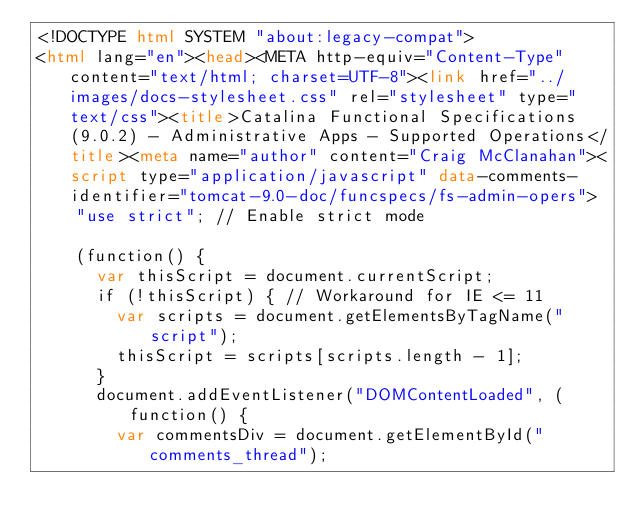Convert code to text. <code><loc_0><loc_0><loc_500><loc_500><_HTML_><!DOCTYPE html SYSTEM "about:legacy-compat">
<html lang="en"><head><META http-equiv="Content-Type" content="text/html; charset=UTF-8"><link href="../images/docs-stylesheet.css" rel="stylesheet" type="text/css"><title>Catalina Functional Specifications (9.0.2) - Administrative Apps - Supported Operations</title><meta name="author" content="Craig McClanahan"><script type="application/javascript" data-comments-identifier="tomcat-9.0-doc/funcspecs/fs-admin-opers">
    "use strict"; // Enable strict mode

    (function() {
      var thisScript = document.currentScript;
      if (!thisScript) { // Workaround for IE <= 11
        var scripts = document.getElementsByTagName("script");
        thisScript = scripts[scripts.length - 1];
      }
      document.addEventListener("DOMContentLoaded", (function() {
        var commentsDiv = document.getElementById("comments_thread");</code> 